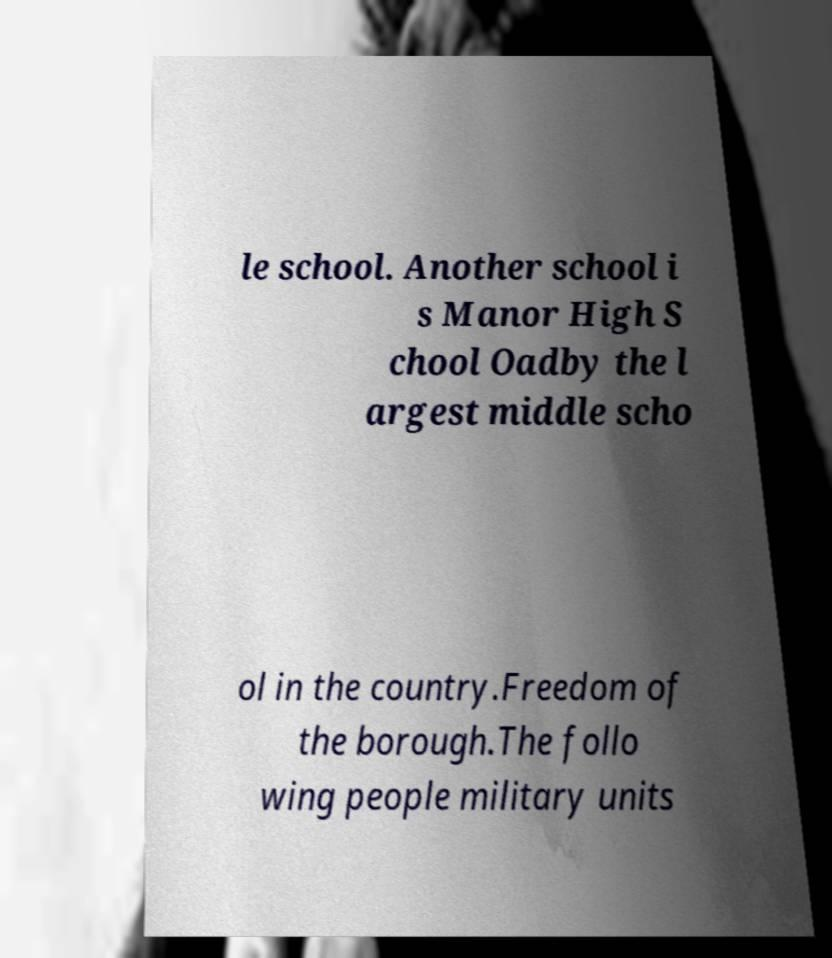I need the written content from this picture converted into text. Can you do that? le school. Another school i s Manor High S chool Oadby the l argest middle scho ol in the country.Freedom of the borough.The follo wing people military units 